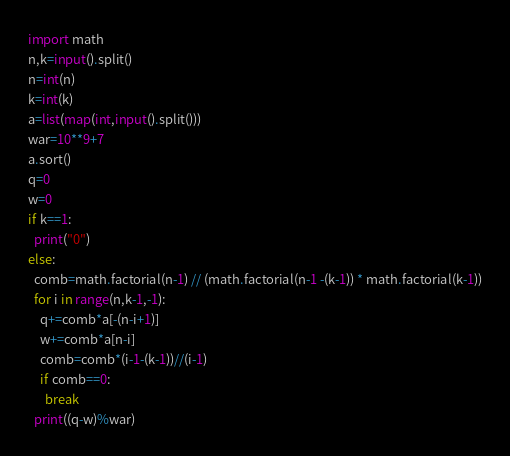Convert code to text. <code><loc_0><loc_0><loc_500><loc_500><_Python_>import math
n,k=input().split()
n=int(n)
k=int(k)
a=list(map(int,input().split()))
war=10**9+7
a.sort()
q=0
w=0
if k==1:
  print("0")
else:
  comb=math.factorial(n-1) // (math.factorial(n-1 -(k-1)) * math.factorial(k-1))
  for i in range(n,k-1,-1):
    q+=comb*a[-(n-i+1)]
    w+=comb*a[n-i]
    comb=comb*(i-1-(k-1))//(i-1)
    if comb==0:
      break
  print((q-w)%war)</code> 